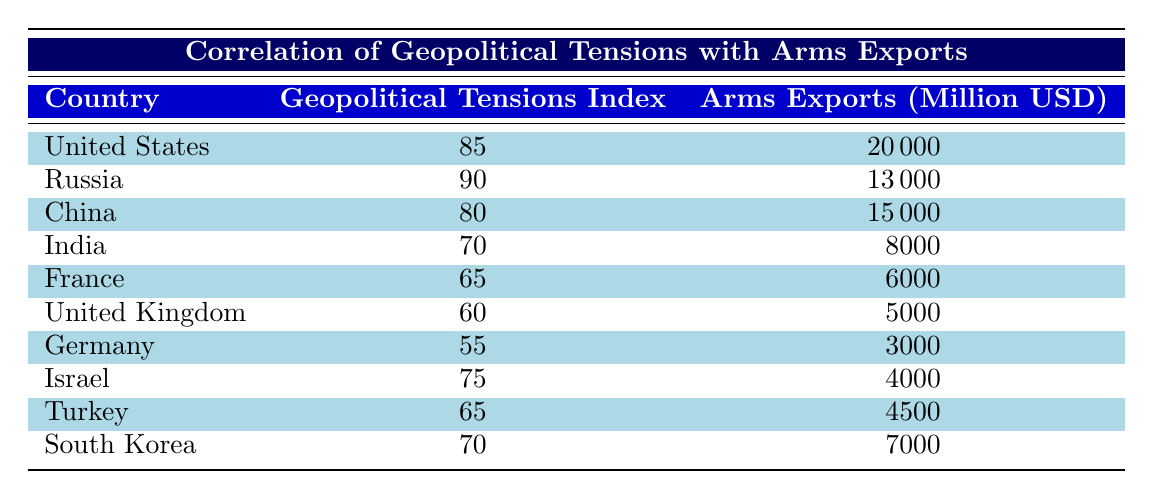What is the arms export value of Russia? According to the table, the arms exports value for Russia is listed directly under the corresponding country. The value is 13000 million USD.
Answer: 13000 million USD Which country has the highest geopolitical tensions index? The geopolitical tensions index for each country is provided in the table. By comparing the values, it can be seen that Russia has the highest index at 90.
Answer: Russia What is the average arms export value for the countries listed? First, we sum up the arms exports values: 20000 + 13000 + 15000 + 8000 + 6000 + 5000 + 3000 + 4000 + 4500 + 7000 = 78000 million USD. There are 10 countries represented, so the average is 78000 / 10 = 7800 million USD.
Answer: 7800 million USD Is the arms export value of the United States greater than the geopolitical tensions index? The arms export value for the United States is 20000 million USD, while the geopolitical tensions index is 85. Since 20000 is greater than 85, the statement is true.
Answer: Yes Which country with a geopolitical tension index above 70 has the lowest arms export value? Identifying countries with an index above 70: United States (85), Russia (90), China (80), and Israel (75). Among these, their respective arms exports are 20000, 13000, 15000, and 4000 million USD. The lowest value is for Israel at 4000 million USD.
Answer: Israel What is the total arms export value for all countries with a geopolitical tensions index below 70? The relevant countries with an index below 70 are India (8000), France (6000), United Kingdom (5000), Germany (3000). Adding these values gives: 8000 + 6000 + 5000 + 3000 = 22000 million USD.
Answer: 22000 million USD Did South Korea have the highest arms export value among countries with a geopolitical tension index of 70? South Korea has an arms export value of 7000 million USD and a geopolitical tensions index of 70. Checking against other countries with the same index (India - 8000 million USD), South Korea does not have the highest.
Answer: No Which countries collectively have arms exports value greater than 25000 million USD and a geopolitical tension index greater than 70? We check the values: United States (20000, 85) and Russia (13000, 90). Their combined arms export value is 20000 + 13000 = 33000 million USD, and both indexes exceed 70. Thus, both countries qualify.
Answer: United States, Russia 